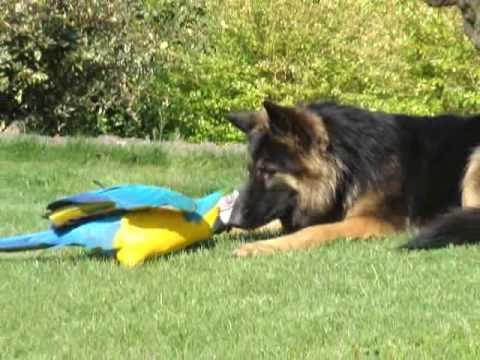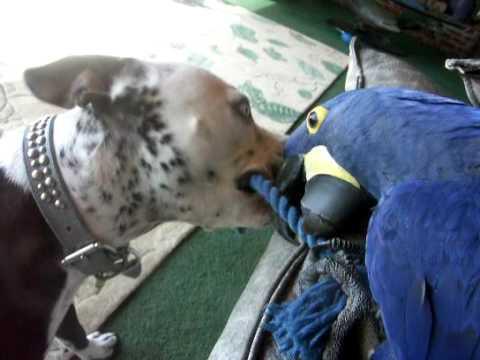The first image is the image on the left, the second image is the image on the right. Given the left and right images, does the statement "There are two dogs and a macaw standing on carpet together in one image." hold true? Answer yes or no. No. The first image is the image on the left, the second image is the image on the right. For the images displayed, is the sentence "A german shepherd plays with a blue and gold macaw." factually correct? Answer yes or no. Yes. 